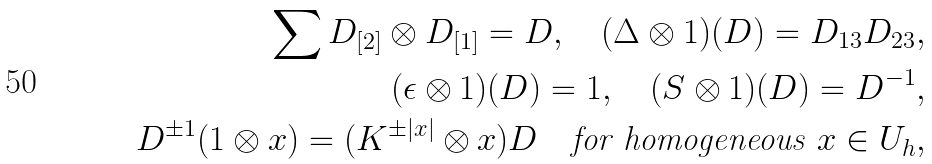Convert formula to latex. <formula><loc_0><loc_0><loc_500><loc_500>\sum D _ { [ 2 ] } \otimes D _ { [ 1 ] } = D , \quad ( \Delta \otimes 1 ) ( D ) = D _ { 1 3 } D _ { 2 3 } , \\ ( \epsilon \otimes 1 ) ( D ) = 1 , \quad ( S \otimes 1 ) ( D ) = D ^ { - 1 } , \\ D ^ { \pm 1 } ( 1 \otimes x ) = ( K ^ { \pm | x | } \otimes x ) D \quad \text {for homogeneous $x\in U_{h}$} ,</formula> 